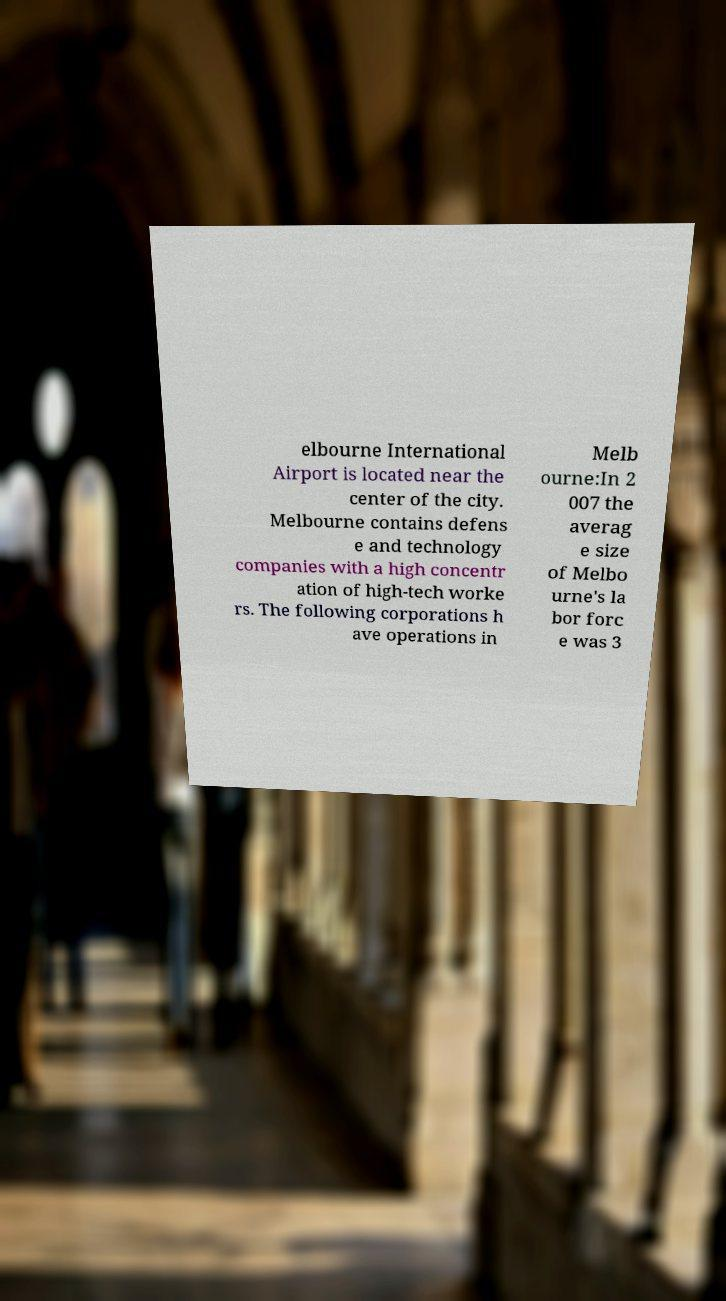Please identify and transcribe the text found in this image. elbourne International Airport is located near the center of the city. Melbourne contains defens e and technology companies with a high concentr ation of high-tech worke rs. The following corporations h ave operations in Melb ourne:In 2 007 the averag e size of Melbo urne's la bor forc e was 3 